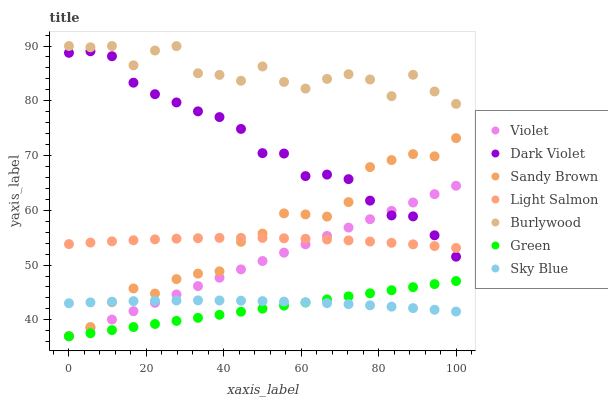Does Green have the minimum area under the curve?
Answer yes or no. Yes. Does Burlywood have the maximum area under the curve?
Answer yes or no. Yes. Does Dark Violet have the minimum area under the curve?
Answer yes or no. No. Does Dark Violet have the maximum area under the curve?
Answer yes or no. No. Is Violet the smoothest?
Answer yes or no. Yes. Is Burlywood the roughest?
Answer yes or no. Yes. Is Dark Violet the smoothest?
Answer yes or no. No. Is Dark Violet the roughest?
Answer yes or no. No. Does Green have the lowest value?
Answer yes or no. Yes. Does Dark Violet have the lowest value?
Answer yes or no. No. Does Burlywood have the highest value?
Answer yes or no. Yes. Does Dark Violet have the highest value?
Answer yes or no. No. Is Dark Violet less than Burlywood?
Answer yes or no. Yes. Is Dark Violet greater than Sky Blue?
Answer yes or no. Yes. Does Sky Blue intersect Violet?
Answer yes or no. Yes. Is Sky Blue less than Violet?
Answer yes or no. No. Is Sky Blue greater than Violet?
Answer yes or no. No. Does Dark Violet intersect Burlywood?
Answer yes or no. No. 